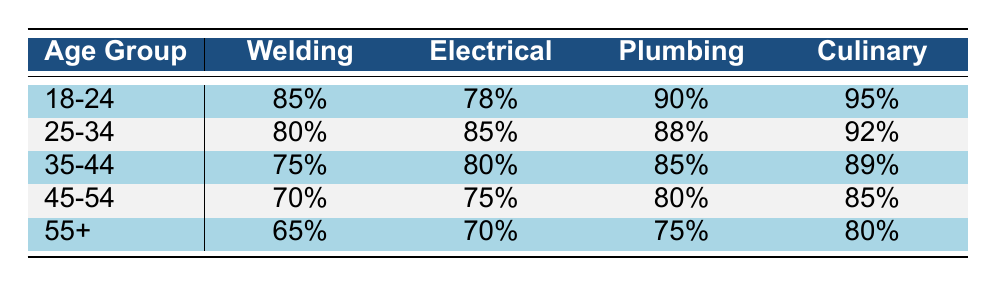What is the course completion rate for the Welding program among students aged 25-34? The table shows the completion rate for the Welding program in the row corresponding to the age group 25-34, which is 80%.
Answer: 80% Which program has the highest completion rate for students aged 18-24? Looking at the row for the age group 18-24, the completion rates are 85% for Welding, 78% for Electrical, 90% for Plumbing, and 95% for Culinary. The highest value is 95% for Culinary.
Answer: 95% Is the completion rate for Electrical higher among students aged 35-44 compared to those aged 45-54? The completion rate for Electrical among students aged 35-44 is 80% and for 45-54 it is 75%. Since 80% is greater than 75%, the claim is true.
Answer: Yes What is the average completion rate for the Plumbing program across all age groups? The completion rates for Plumbing are 90% (18-24), 88% (25-34), 85% (35-44), 80% (45-54), and 75% (55+). Summing these values gives us 90 + 88 + 85 + 80 + 75 = 418, and dividing by 5 (total groups) gives us the average: 418/5 = 83.6%.
Answer: 83.6% Do students aged 55 and older have a higher completion rate in Culinary than in Welding? For the age group 55+, the completion rate for Culinary is 80%, while for Welding it is 65%. Since 80% is greater than 65%, the statement is true.
Answer: Yes What is the difference in completion rates between the Culinary and Electrical programs for students aged 45-54? The completion rate for Culinary is 85% and for Electrical it is 75%. The difference is 85% - 75% = 10%.
Answer: 10% Which age group has the lowest overall course completion rates across all programs? By reviewing the completion rates, for Welding 65%, Electrical 70%, Plumbing 75%, and Culinary 80% are the lowest for the age group 55+.
Answer: 55+ What is the total completion rate for the Welding program across all age groups? The completion rates for Welding are 85% (18-24), 80% (25-34), 75% (35-44), 70% (45-54), and 65% (55+). Adding these together gives 85 + 80 + 75 + 70 + 65 = 375.
Answer: 375 